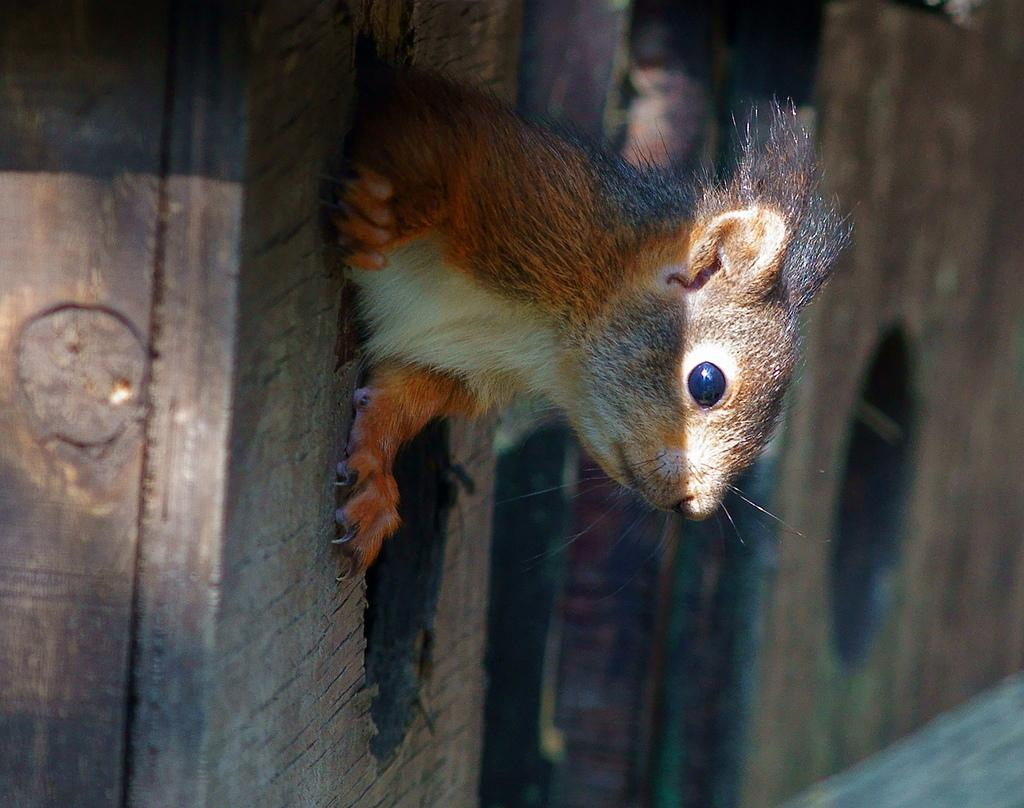What is the main subject in the center of the image? There is an animal in the center of the image. What type of material is used for the wall in the image? There is a wooden wall in the image. What can be seen at the bottom of the image? There is a walkway at the bottom of the image. What type of toys are scattered around the animal in the image? There are no toys present in the image; it features an animal, a wooden wall, and a walkway. 